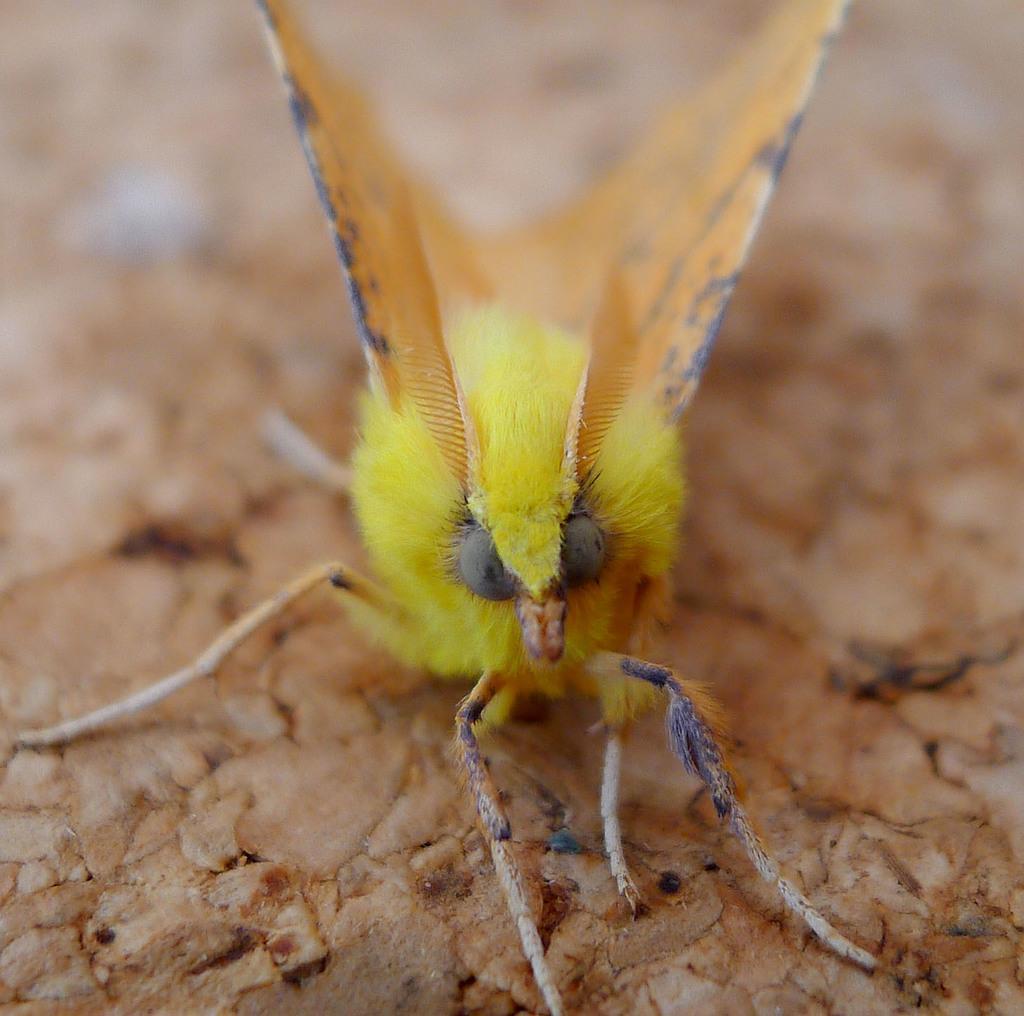How would you summarize this image in a sentence or two? In the center of the image there is a insect on the surface. 